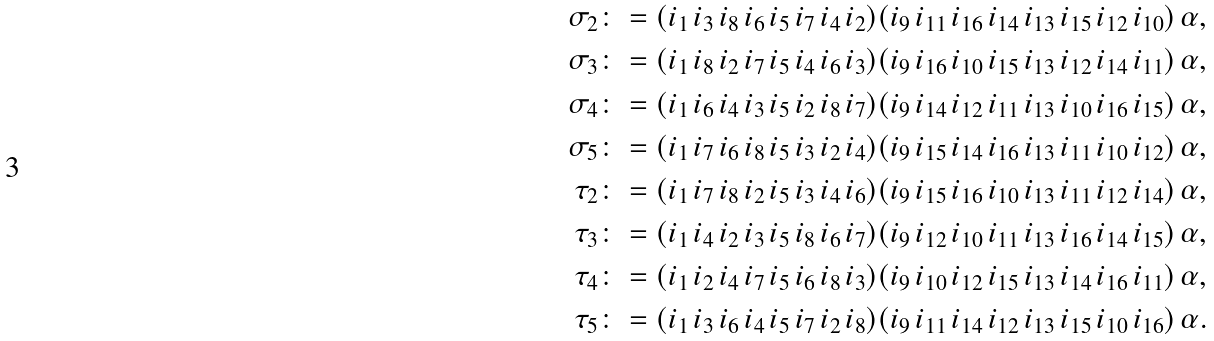<formula> <loc_0><loc_0><loc_500><loc_500>\sigma _ { 2 } & \colon = ( i _ { 1 } \, i _ { 3 } \, i _ { 8 } \, i _ { 6 } \, i _ { 5 } \, i _ { 7 } \, i _ { 4 } \, i _ { 2 } ) ( i _ { 9 } \, i _ { 1 1 } \, i _ { 1 6 } \, i _ { 1 4 } \, i _ { 1 3 } \, i _ { 1 5 } \, i _ { 1 2 } \, i _ { 1 0 } ) \, \alpha , \\ \sigma _ { 3 } & \colon = ( i _ { 1 } \, i _ { 8 } \, i _ { 2 } \, i _ { 7 } \, i _ { 5 } \, i _ { 4 } \, i _ { 6 } \, i _ { 3 } ) ( i _ { 9 } \, i _ { 1 6 } \, i _ { 1 0 } \, i _ { 1 5 } \, i _ { 1 3 } \, i _ { 1 2 } \, i _ { 1 4 } \, i _ { 1 1 } ) \, \alpha , \\ \sigma _ { 4 } & \colon = ( i _ { 1 } \, i _ { 6 } \, i _ { 4 } \, i _ { 3 } \, i _ { 5 } \, i _ { 2 } \, i _ { 8 } \, i _ { 7 } ) ( i _ { 9 } \, i _ { 1 4 } \, i _ { 1 2 } \, i _ { 1 1 } \, i _ { 1 3 } \, i _ { 1 0 } \, i _ { 1 6 } \, i _ { 1 5 } ) \, \alpha , \\ \sigma _ { 5 } & \colon = ( i _ { 1 } \, i _ { 7 } \, i _ { 6 } \, i _ { 8 } \, i _ { 5 } \, i _ { 3 } \, i _ { 2 } \, i _ { 4 } ) ( i _ { 9 } \, i _ { 1 5 } \, i _ { 1 4 } \, i _ { 1 6 } \, i _ { 1 3 } \, i _ { 1 1 } \, i _ { 1 0 } \, i _ { 1 2 } ) \, \alpha , \\ \tau _ { 2 } & \colon = ( i _ { 1 } \, i _ { 7 } \, i _ { 8 } \, i _ { 2 } \, i _ { 5 } \, i _ { 3 } \, i _ { 4 } \, i _ { 6 } ) ( i _ { 9 } \, i _ { 1 5 } \, i _ { 1 6 } \, i _ { 1 0 } \, i _ { 1 3 } \, i _ { 1 1 } \, i _ { 1 2 } \, i _ { 1 4 } ) \, \alpha , \\ \tau _ { 3 } & \colon = ( i _ { 1 } \, i _ { 4 } \, i _ { 2 } \, i _ { 3 } \, i _ { 5 } \, i _ { 8 } \, i _ { 6 } \, i _ { 7 } ) ( i _ { 9 } \, i _ { 1 2 } \, i _ { 1 0 } \, i _ { 1 1 } \, i _ { 1 3 } \, i _ { 1 6 } \, i _ { 1 4 } \, i _ { 1 5 } ) \, \alpha , \\ \tau _ { 4 } & \colon = ( i _ { 1 } \, i _ { 2 } \, i _ { 4 } \, i _ { 7 } \, i _ { 5 } \, i _ { 6 } \, i _ { 8 } \, i _ { 3 } ) ( i _ { 9 } \, i _ { 1 0 } \, i _ { 1 2 } \, i _ { 1 5 } \, i _ { 1 3 } \, i _ { 1 4 } \, i _ { 1 6 } \, i _ { 1 1 } ) \, \alpha , \\ \tau _ { 5 } & \colon = ( i _ { 1 } \, i _ { 3 } \, i _ { 6 } \, i _ { 4 } \, i _ { 5 } \, i _ { 7 } \, i _ { 2 } \, i _ { 8 } ) ( i _ { 9 } \, i _ { 1 1 } \, i _ { 1 4 } \, i _ { 1 2 } \, i _ { 1 3 } \, i _ { 1 5 } \, i _ { 1 0 } \, i _ { 1 6 } ) \, \alpha .</formula> 